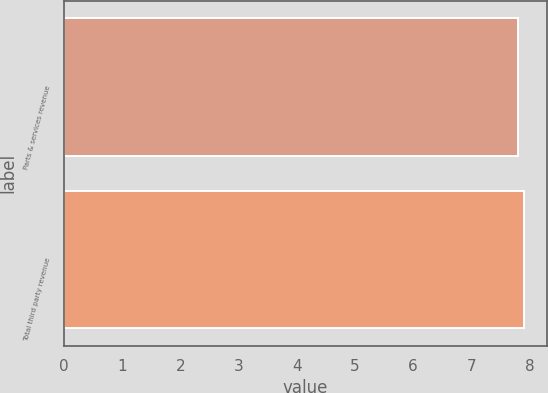Convert chart to OTSL. <chart><loc_0><loc_0><loc_500><loc_500><bar_chart><fcel>Parts & services revenue<fcel>Total third party revenue<nl><fcel>7.8<fcel>7.9<nl></chart> 